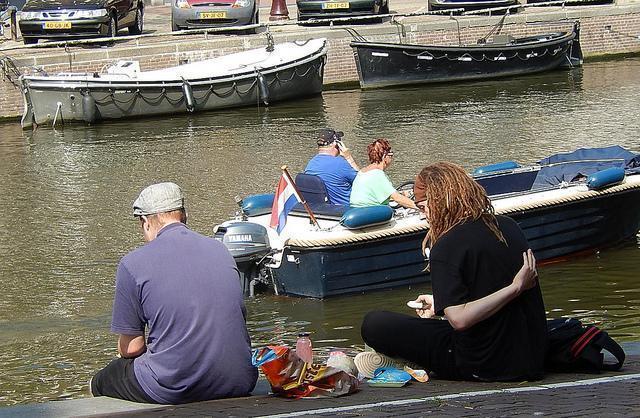A small vessel for travelling over water propelled by oars sails or an engine is?
Answer the question by selecting the correct answer among the 4 following choices.
Options: Flight, boat, ship, floater. Boat. 